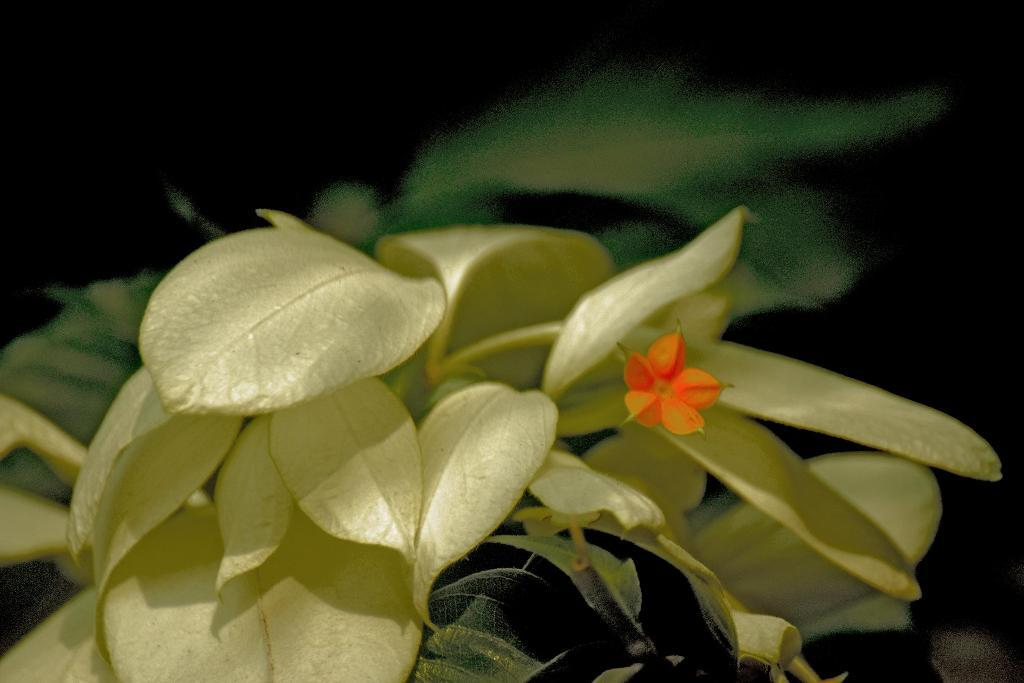What type of living organism can be seen in the image? There is a flower in the image. What else can be seen in the image besides the flower? There are plants in the image. What is the color of the background in the image? The background of the image is dark. Can you tell me how the flower moves around in the image using magic? There is no magic or movement of the flower in the image; it is stationary. What type of trousers is the flower wearing in the image? Flowers do not wear trousers, as they are plants and not human beings. 